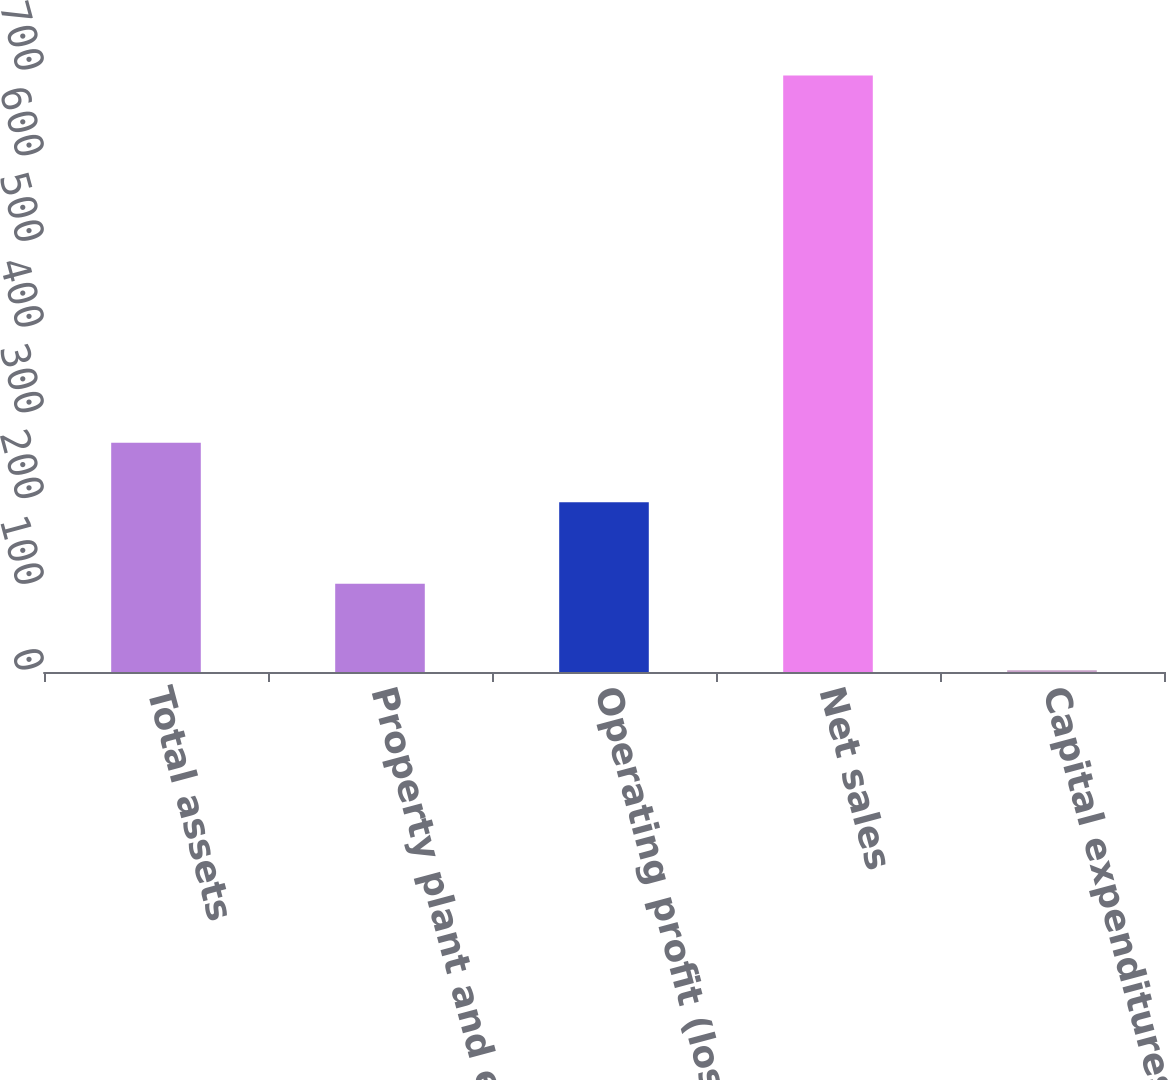<chart> <loc_0><loc_0><loc_500><loc_500><bar_chart><fcel>Total assets<fcel>Property plant and equipment<fcel>Operating profit (loss)<fcel>Net sales<fcel>Capital expenditures<nl><fcel>267.4<fcel>103<fcel>198<fcel>696<fcel>2<nl></chart> 